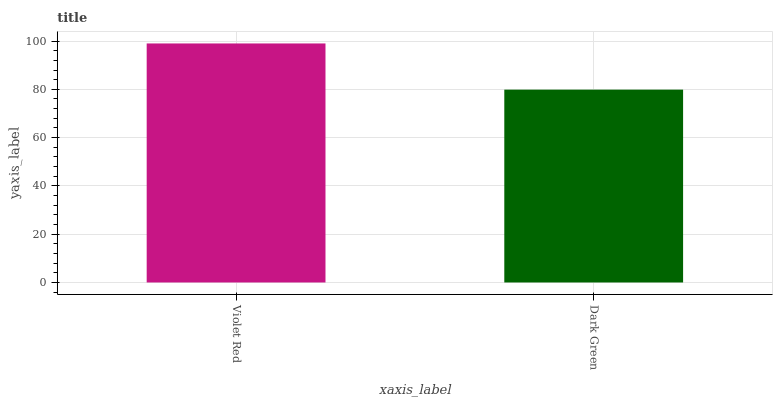Is Dark Green the minimum?
Answer yes or no. Yes. Is Violet Red the maximum?
Answer yes or no. Yes. Is Dark Green the maximum?
Answer yes or no. No. Is Violet Red greater than Dark Green?
Answer yes or no. Yes. Is Dark Green less than Violet Red?
Answer yes or no. Yes. Is Dark Green greater than Violet Red?
Answer yes or no. No. Is Violet Red less than Dark Green?
Answer yes or no. No. Is Violet Red the high median?
Answer yes or no. Yes. Is Dark Green the low median?
Answer yes or no. Yes. Is Dark Green the high median?
Answer yes or no. No. Is Violet Red the low median?
Answer yes or no. No. 